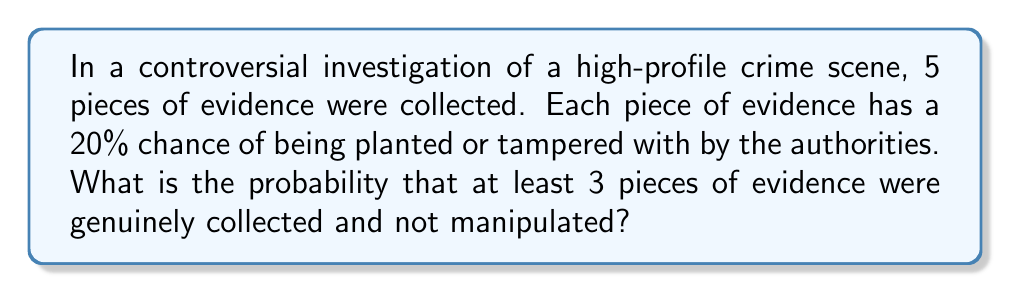Provide a solution to this math problem. Let's approach this step-by-step:

1) First, we need to recognize that this is a binomial probability problem. We have 5 independent trials (pieces of evidence), each with a success probability of 80% (not being tampered with).

2) We're looking for the probability of at least 3 successes out of 5 trials. This is equivalent to the probability of 3, 4, or 5 successes.

3) The probability of exactly k successes in n trials is given by the binomial probability formula:

   $$P(X = k) = \binom{n}{k} p^k (1-p)^{n-k}$$

   where $n$ is the number of trials, $k$ is the number of successes, $p$ is the probability of success on each trial.

4) In our case, $n = 5$, $p = 0.8$, and we need to calculate for $k = 3$, $k = 4$, and $k = 5$.

5) For $k = 3$:
   $$P(X = 3) = \binom{5}{3} (0.8)^3 (0.2)^2 = 10 \times 0.512 \times 0.04 = 0.2048$$

6) For $k = 4$:
   $$P(X = 4) = \binom{5}{4} (0.8)^4 (0.2)^1 = 5 \times 0.4096 \times 0.2 = 0.4096$$

7) For $k = 5$:
   $$P(X = 5) = \binom{5}{5} (0.8)^5 (0.2)^0 = 1 \times 0.32768 \times 1 = 0.32768$$

8) The total probability is the sum of these three probabilities:
   $$P(X \geq 3) = 0.2048 + 0.4096 + 0.32768 = 0.94208$$
Answer: 0.94208 